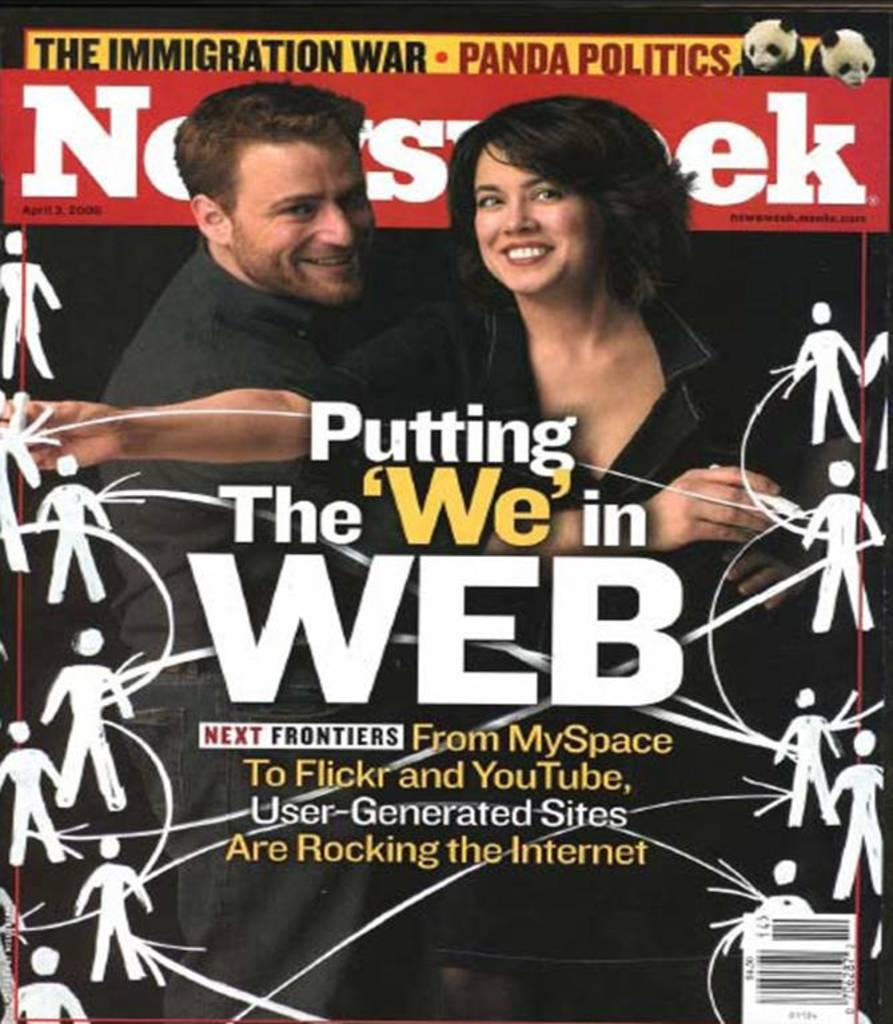<image>
Create a compact narrative representing the image presented. Mgazine cover titled "Putting the We in Web". 